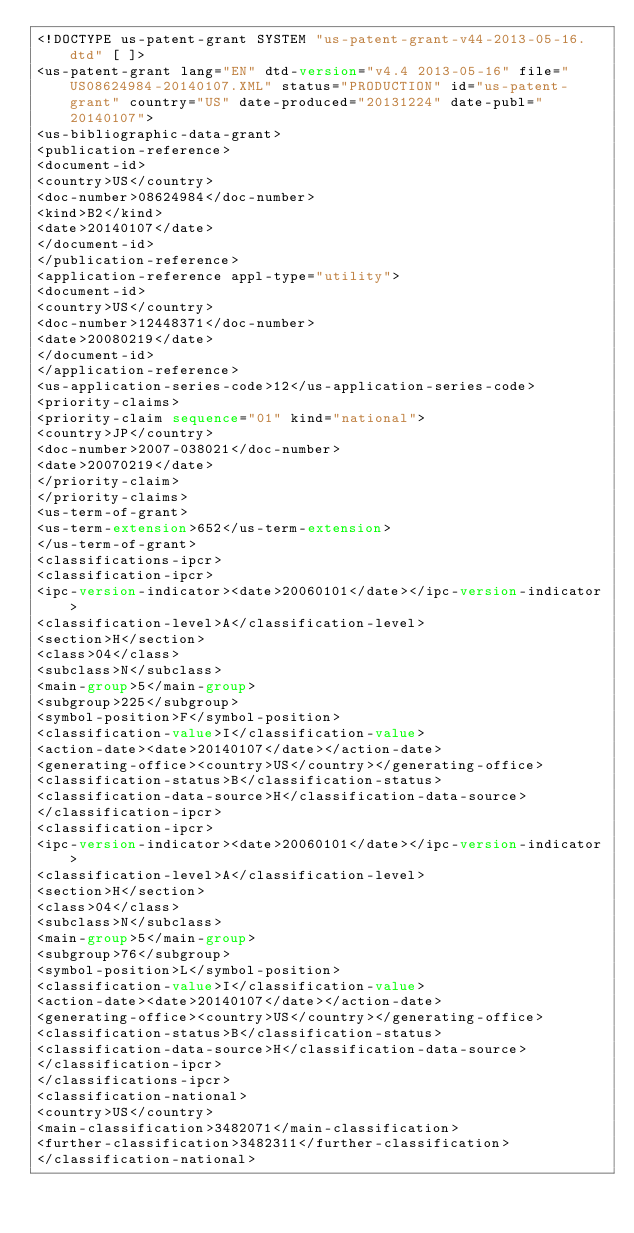<code> <loc_0><loc_0><loc_500><loc_500><_XML_><!DOCTYPE us-patent-grant SYSTEM "us-patent-grant-v44-2013-05-16.dtd" [ ]>
<us-patent-grant lang="EN" dtd-version="v4.4 2013-05-16" file="US08624984-20140107.XML" status="PRODUCTION" id="us-patent-grant" country="US" date-produced="20131224" date-publ="20140107">
<us-bibliographic-data-grant>
<publication-reference>
<document-id>
<country>US</country>
<doc-number>08624984</doc-number>
<kind>B2</kind>
<date>20140107</date>
</document-id>
</publication-reference>
<application-reference appl-type="utility">
<document-id>
<country>US</country>
<doc-number>12448371</doc-number>
<date>20080219</date>
</document-id>
</application-reference>
<us-application-series-code>12</us-application-series-code>
<priority-claims>
<priority-claim sequence="01" kind="national">
<country>JP</country>
<doc-number>2007-038021</doc-number>
<date>20070219</date>
</priority-claim>
</priority-claims>
<us-term-of-grant>
<us-term-extension>652</us-term-extension>
</us-term-of-grant>
<classifications-ipcr>
<classification-ipcr>
<ipc-version-indicator><date>20060101</date></ipc-version-indicator>
<classification-level>A</classification-level>
<section>H</section>
<class>04</class>
<subclass>N</subclass>
<main-group>5</main-group>
<subgroup>225</subgroup>
<symbol-position>F</symbol-position>
<classification-value>I</classification-value>
<action-date><date>20140107</date></action-date>
<generating-office><country>US</country></generating-office>
<classification-status>B</classification-status>
<classification-data-source>H</classification-data-source>
</classification-ipcr>
<classification-ipcr>
<ipc-version-indicator><date>20060101</date></ipc-version-indicator>
<classification-level>A</classification-level>
<section>H</section>
<class>04</class>
<subclass>N</subclass>
<main-group>5</main-group>
<subgroup>76</subgroup>
<symbol-position>L</symbol-position>
<classification-value>I</classification-value>
<action-date><date>20140107</date></action-date>
<generating-office><country>US</country></generating-office>
<classification-status>B</classification-status>
<classification-data-source>H</classification-data-source>
</classification-ipcr>
</classifications-ipcr>
<classification-national>
<country>US</country>
<main-classification>3482071</main-classification>
<further-classification>3482311</further-classification>
</classification-national></code> 